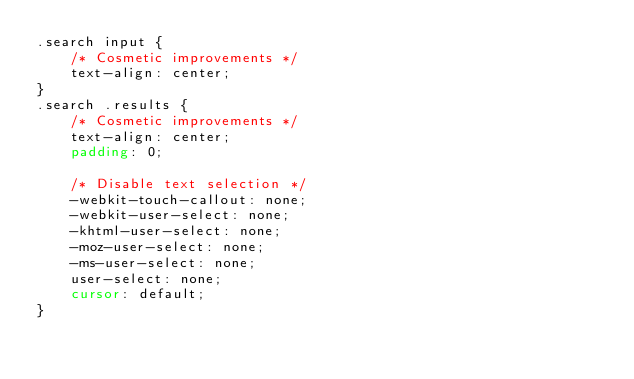<code> <loc_0><loc_0><loc_500><loc_500><_CSS_>.search input {
	/* Cosmetic improvements */
	text-align: center;
}
.search .results {
	/* Cosmetic improvements */
	text-align: center;
	padding: 0;

	/* Disable text selection */
	-webkit-touch-callout: none;
	-webkit-user-select: none;
	-khtml-user-select: none;
	-moz-user-select: none;
	-ms-user-select: none;
	user-select: none;
	cursor: default;
}
</code> 